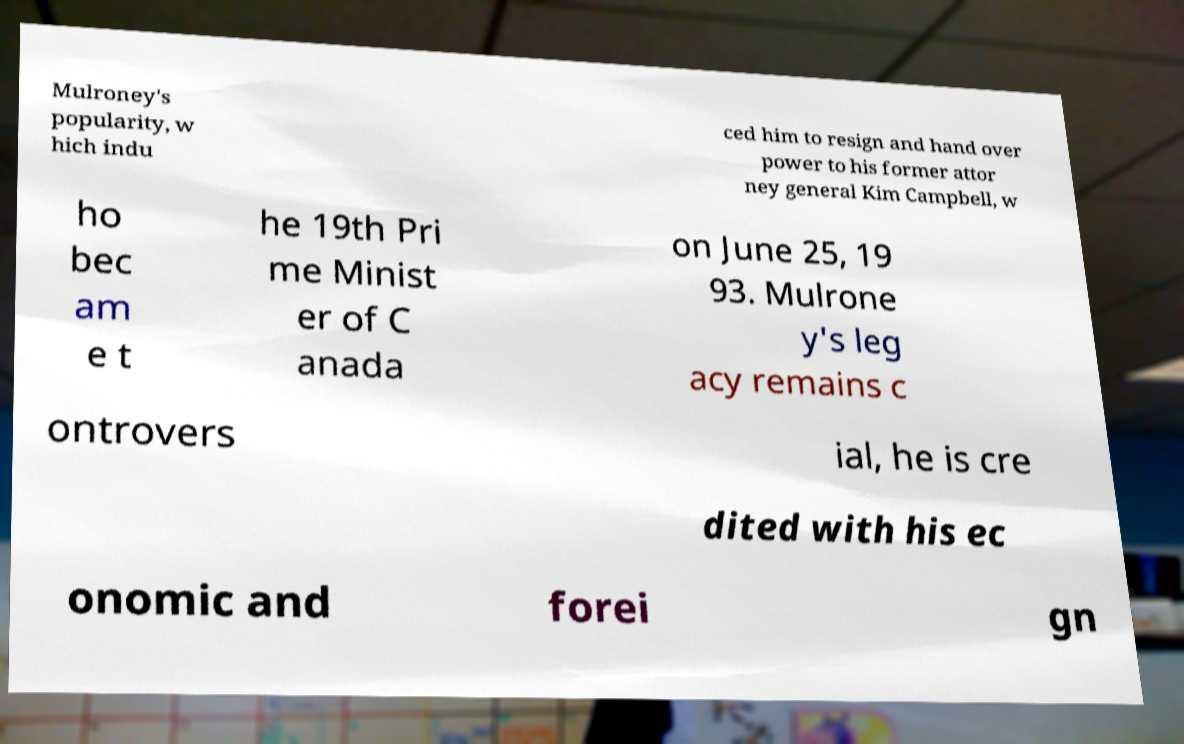Please read and relay the text visible in this image. What does it say? Mulroney's popularity, w hich indu ced him to resign and hand over power to his former attor ney general Kim Campbell, w ho bec am e t he 19th Pri me Minist er of C anada on June 25, 19 93. Mulrone y's leg acy remains c ontrovers ial, he is cre dited with his ec onomic and forei gn 